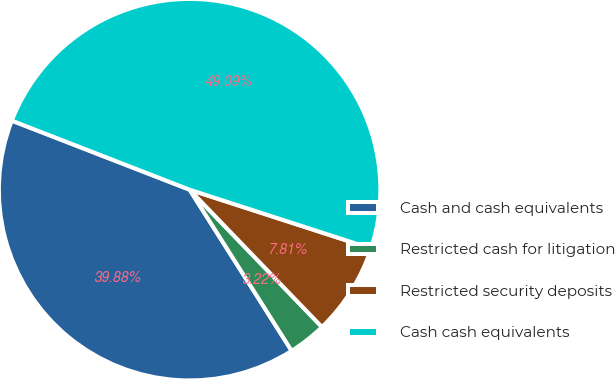<chart> <loc_0><loc_0><loc_500><loc_500><pie_chart><fcel>Cash and cash equivalents<fcel>Restricted cash for litigation<fcel>Restricted security deposits<fcel>Cash cash equivalents<nl><fcel>39.88%<fcel>3.22%<fcel>7.81%<fcel>49.09%<nl></chart> 